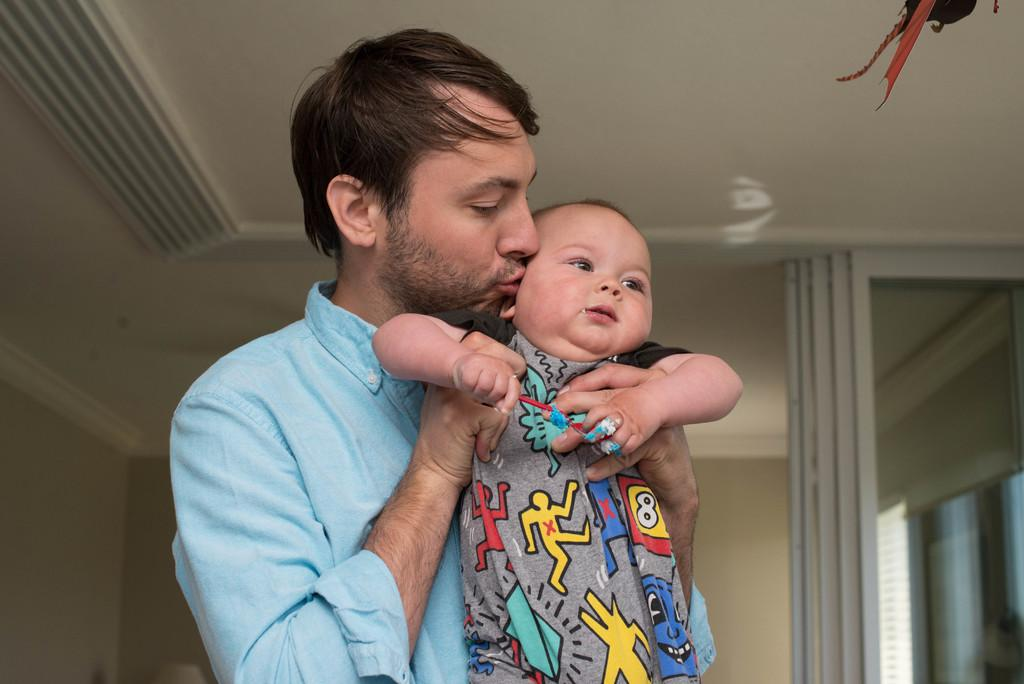What is the main subject of the image? There is a person in the image. What is the person wearing? The person is wearing a yellow t-shirt. What is the person holding? The person is holding a baby. What can be seen in the background of the image? There is a wall and a roof in the background of the image. What type of ray is flying over the person in the image? There is no ray present in the image. 